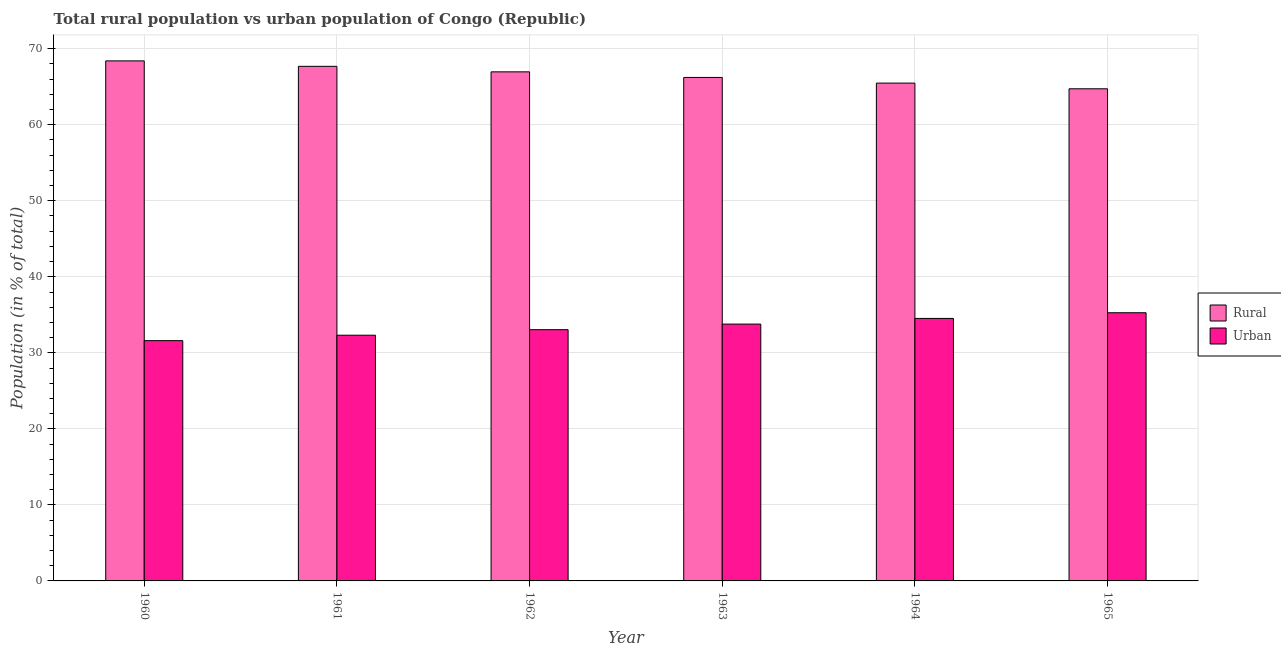How many groups of bars are there?
Your response must be concise. 6. Are the number of bars per tick equal to the number of legend labels?
Ensure brevity in your answer.  Yes. How many bars are there on the 3rd tick from the right?
Provide a short and direct response. 2. What is the rural population in 1964?
Make the answer very short. 65.48. Across all years, what is the maximum rural population?
Offer a terse response. 68.4. Across all years, what is the minimum urban population?
Your answer should be compact. 31.6. In which year was the urban population maximum?
Give a very brief answer. 1965. In which year was the rural population minimum?
Your response must be concise. 1965. What is the total urban population in the graph?
Your answer should be very brief. 200.54. What is the difference between the urban population in 1960 and that in 1963?
Offer a very short reply. -2.18. What is the difference between the urban population in 1960 and the rural population in 1965?
Provide a short and direct response. -3.67. What is the average urban population per year?
Offer a terse response. 33.42. In the year 1964, what is the difference between the urban population and rural population?
Offer a terse response. 0. What is the ratio of the rural population in 1964 to that in 1965?
Offer a terse response. 1.01. What is the difference between the highest and the second highest urban population?
Ensure brevity in your answer.  0.75. What is the difference between the highest and the lowest rural population?
Make the answer very short. 3.67. Is the sum of the rural population in 1961 and 1964 greater than the maximum urban population across all years?
Your response must be concise. Yes. What does the 1st bar from the left in 1964 represents?
Your answer should be compact. Rural. What does the 2nd bar from the right in 1964 represents?
Your response must be concise. Rural. How many bars are there?
Your answer should be compact. 12. Are all the bars in the graph horizontal?
Your answer should be very brief. No. What is the difference between two consecutive major ticks on the Y-axis?
Offer a terse response. 10. Does the graph contain grids?
Keep it short and to the point. Yes. Where does the legend appear in the graph?
Provide a succinct answer. Center right. How many legend labels are there?
Your answer should be compact. 2. How are the legend labels stacked?
Ensure brevity in your answer.  Vertical. What is the title of the graph?
Your answer should be compact. Total rural population vs urban population of Congo (Republic). What is the label or title of the Y-axis?
Provide a succinct answer. Population (in % of total). What is the Population (in % of total) in Rural in 1960?
Your response must be concise. 68.4. What is the Population (in % of total) of Urban in 1960?
Keep it short and to the point. 31.6. What is the Population (in % of total) of Rural in 1961?
Offer a terse response. 67.68. What is the Population (in % of total) in Urban in 1961?
Your answer should be compact. 32.32. What is the Population (in % of total) of Rural in 1962?
Ensure brevity in your answer.  66.95. What is the Population (in % of total) in Urban in 1962?
Your answer should be very brief. 33.05. What is the Population (in % of total) in Rural in 1963?
Your response must be concise. 66.22. What is the Population (in % of total) of Urban in 1963?
Ensure brevity in your answer.  33.78. What is the Population (in % of total) of Rural in 1964?
Provide a succinct answer. 65.48. What is the Population (in % of total) of Urban in 1964?
Ensure brevity in your answer.  34.52. What is the Population (in % of total) of Rural in 1965?
Ensure brevity in your answer.  64.73. What is the Population (in % of total) of Urban in 1965?
Offer a terse response. 35.27. Across all years, what is the maximum Population (in % of total) of Rural?
Keep it short and to the point. 68.4. Across all years, what is the maximum Population (in % of total) of Urban?
Your answer should be very brief. 35.27. Across all years, what is the minimum Population (in % of total) in Rural?
Your answer should be very brief. 64.73. Across all years, what is the minimum Population (in % of total) in Urban?
Your response must be concise. 31.6. What is the total Population (in % of total) in Rural in the graph?
Offer a terse response. 399.46. What is the total Population (in % of total) in Urban in the graph?
Offer a terse response. 200.54. What is the difference between the Population (in % of total) of Rural in 1960 and that in 1961?
Offer a very short reply. 0.72. What is the difference between the Population (in % of total) of Urban in 1960 and that in 1961?
Offer a terse response. -0.72. What is the difference between the Population (in % of total) of Rural in 1960 and that in 1962?
Your answer should be compact. 1.44. What is the difference between the Population (in % of total) of Urban in 1960 and that in 1962?
Your response must be concise. -1.44. What is the difference between the Population (in % of total) of Rural in 1960 and that in 1963?
Provide a short and direct response. 2.18. What is the difference between the Population (in % of total) in Urban in 1960 and that in 1963?
Your answer should be compact. -2.18. What is the difference between the Population (in % of total) in Rural in 1960 and that in 1964?
Your response must be concise. 2.92. What is the difference between the Population (in % of total) in Urban in 1960 and that in 1964?
Your response must be concise. -2.92. What is the difference between the Population (in % of total) of Rural in 1960 and that in 1965?
Offer a very short reply. 3.67. What is the difference between the Population (in % of total) of Urban in 1960 and that in 1965?
Your answer should be very brief. -3.67. What is the difference between the Population (in % of total) of Rural in 1961 and that in 1962?
Offer a terse response. 0.73. What is the difference between the Population (in % of total) of Urban in 1961 and that in 1962?
Your answer should be compact. -0.73. What is the difference between the Population (in % of total) of Rural in 1961 and that in 1963?
Your response must be concise. 1.46. What is the difference between the Population (in % of total) in Urban in 1961 and that in 1963?
Offer a terse response. -1.46. What is the difference between the Population (in % of total) in Rural in 1961 and that in 1964?
Your response must be concise. 2.21. What is the difference between the Population (in % of total) in Urban in 1961 and that in 1964?
Your answer should be compact. -2.21. What is the difference between the Population (in % of total) of Rural in 1961 and that in 1965?
Ensure brevity in your answer.  2.96. What is the difference between the Population (in % of total) of Urban in 1961 and that in 1965?
Provide a short and direct response. -2.96. What is the difference between the Population (in % of total) of Rural in 1962 and that in 1963?
Your response must be concise. 0.73. What is the difference between the Population (in % of total) of Urban in 1962 and that in 1963?
Keep it short and to the point. -0.73. What is the difference between the Population (in % of total) of Rural in 1962 and that in 1964?
Your response must be concise. 1.48. What is the difference between the Population (in % of total) of Urban in 1962 and that in 1964?
Offer a terse response. -1.48. What is the difference between the Population (in % of total) in Rural in 1962 and that in 1965?
Make the answer very short. 2.23. What is the difference between the Population (in % of total) of Urban in 1962 and that in 1965?
Offer a terse response. -2.23. What is the difference between the Population (in % of total) of Rural in 1963 and that in 1964?
Make the answer very short. 0.74. What is the difference between the Population (in % of total) in Urban in 1963 and that in 1964?
Offer a terse response. -0.74. What is the difference between the Population (in % of total) in Rural in 1963 and that in 1965?
Make the answer very short. 1.49. What is the difference between the Population (in % of total) in Urban in 1963 and that in 1965?
Ensure brevity in your answer.  -1.49. What is the difference between the Population (in % of total) in Rural in 1964 and that in 1965?
Make the answer very short. 0.75. What is the difference between the Population (in % of total) of Urban in 1964 and that in 1965?
Keep it short and to the point. -0.75. What is the difference between the Population (in % of total) in Rural in 1960 and the Population (in % of total) in Urban in 1961?
Your answer should be compact. 36.08. What is the difference between the Population (in % of total) of Rural in 1960 and the Population (in % of total) of Urban in 1962?
Provide a succinct answer. 35.35. What is the difference between the Population (in % of total) in Rural in 1960 and the Population (in % of total) in Urban in 1963?
Make the answer very short. 34.62. What is the difference between the Population (in % of total) of Rural in 1960 and the Population (in % of total) of Urban in 1964?
Offer a terse response. 33.88. What is the difference between the Population (in % of total) in Rural in 1960 and the Population (in % of total) in Urban in 1965?
Offer a very short reply. 33.13. What is the difference between the Population (in % of total) of Rural in 1961 and the Population (in % of total) of Urban in 1962?
Keep it short and to the point. 34.64. What is the difference between the Population (in % of total) of Rural in 1961 and the Population (in % of total) of Urban in 1963?
Offer a terse response. 33.9. What is the difference between the Population (in % of total) of Rural in 1961 and the Population (in % of total) of Urban in 1964?
Your answer should be very brief. 33.16. What is the difference between the Population (in % of total) in Rural in 1961 and the Population (in % of total) in Urban in 1965?
Your answer should be very brief. 32.41. What is the difference between the Population (in % of total) in Rural in 1962 and the Population (in % of total) in Urban in 1963?
Your answer should be compact. 33.17. What is the difference between the Population (in % of total) in Rural in 1962 and the Population (in % of total) in Urban in 1964?
Your answer should be compact. 32.43. What is the difference between the Population (in % of total) of Rural in 1962 and the Population (in % of total) of Urban in 1965?
Offer a very short reply. 31.68. What is the difference between the Population (in % of total) in Rural in 1963 and the Population (in % of total) in Urban in 1964?
Make the answer very short. 31.7. What is the difference between the Population (in % of total) of Rural in 1963 and the Population (in % of total) of Urban in 1965?
Offer a very short reply. 30.95. What is the difference between the Population (in % of total) in Rural in 1964 and the Population (in % of total) in Urban in 1965?
Offer a terse response. 30.2. What is the average Population (in % of total) in Rural per year?
Ensure brevity in your answer.  66.58. What is the average Population (in % of total) in Urban per year?
Keep it short and to the point. 33.42. In the year 1960, what is the difference between the Population (in % of total) of Rural and Population (in % of total) of Urban?
Offer a terse response. 36.8. In the year 1961, what is the difference between the Population (in % of total) in Rural and Population (in % of total) in Urban?
Offer a terse response. 35.36. In the year 1962, what is the difference between the Population (in % of total) in Rural and Population (in % of total) in Urban?
Offer a terse response. 33.91. In the year 1963, what is the difference between the Population (in % of total) of Rural and Population (in % of total) of Urban?
Provide a succinct answer. 32.44. In the year 1964, what is the difference between the Population (in % of total) of Rural and Population (in % of total) of Urban?
Make the answer very short. 30.95. In the year 1965, what is the difference between the Population (in % of total) in Rural and Population (in % of total) in Urban?
Your answer should be compact. 29.45. What is the ratio of the Population (in % of total) in Rural in 1960 to that in 1961?
Give a very brief answer. 1.01. What is the ratio of the Population (in % of total) in Urban in 1960 to that in 1961?
Keep it short and to the point. 0.98. What is the ratio of the Population (in % of total) in Rural in 1960 to that in 1962?
Your response must be concise. 1.02. What is the ratio of the Population (in % of total) of Urban in 1960 to that in 1962?
Ensure brevity in your answer.  0.96. What is the ratio of the Population (in % of total) in Rural in 1960 to that in 1963?
Provide a short and direct response. 1.03. What is the ratio of the Population (in % of total) of Urban in 1960 to that in 1963?
Ensure brevity in your answer.  0.94. What is the ratio of the Population (in % of total) of Rural in 1960 to that in 1964?
Give a very brief answer. 1.04. What is the ratio of the Population (in % of total) in Urban in 1960 to that in 1964?
Your answer should be compact. 0.92. What is the ratio of the Population (in % of total) in Rural in 1960 to that in 1965?
Keep it short and to the point. 1.06. What is the ratio of the Population (in % of total) of Urban in 1960 to that in 1965?
Your answer should be compact. 0.9. What is the ratio of the Population (in % of total) in Rural in 1961 to that in 1962?
Offer a very short reply. 1.01. What is the ratio of the Population (in % of total) in Rural in 1961 to that in 1963?
Ensure brevity in your answer.  1.02. What is the ratio of the Population (in % of total) in Urban in 1961 to that in 1963?
Your answer should be very brief. 0.96. What is the ratio of the Population (in % of total) of Rural in 1961 to that in 1964?
Your answer should be compact. 1.03. What is the ratio of the Population (in % of total) in Urban in 1961 to that in 1964?
Ensure brevity in your answer.  0.94. What is the ratio of the Population (in % of total) in Rural in 1961 to that in 1965?
Make the answer very short. 1.05. What is the ratio of the Population (in % of total) in Urban in 1961 to that in 1965?
Give a very brief answer. 0.92. What is the ratio of the Population (in % of total) of Rural in 1962 to that in 1963?
Your response must be concise. 1.01. What is the ratio of the Population (in % of total) of Urban in 1962 to that in 1963?
Keep it short and to the point. 0.98. What is the ratio of the Population (in % of total) in Rural in 1962 to that in 1964?
Make the answer very short. 1.02. What is the ratio of the Population (in % of total) in Urban in 1962 to that in 1964?
Give a very brief answer. 0.96. What is the ratio of the Population (in % of total) in Rural in 1962 to that in 1965?
Provide a short and direct response. 1.03. What is the ratio of the Population (in % of total) of Urban in 1962 to that in 1965?
Give a very brief answer. 0.94. What is the ratio of the Population (in % of total) of Rural in 1963 to that in 1964?
Provide a succinct answer. 1.01. What is the ratio of the Population (in % of total) in Urban in 1963 to that in 1964?
Your answer should be compact. 0.98. What is the ratio of the Population (in % of total) of Rural in 1963 to that in 1965?
Offer a very short reply. 1.02. What is the ratio of the Population (in % of total) in Urban in 1963 to that in 1965?
Make the answer very short. 0.96. What is the ratio of the Population (in % of total) of Rural in 1964 to that in 1965?
Provide a succinct answer. 1.01. What is the ratio of the Population (in % of total) of Urban in 1964 to that in 1965?
Give a very brief answer. 0.98. What is the difference between the highest and the second highest Population (in % of total) of Rural?
Offer a terse response. 0.72. What is the difference between the highest and the second highest Population (in % of total) in Urban?
Give a very brief answer. 0.75. What is the difference between the highest and the lowest Population (in % of total) of Rural?
Your answer should be very brief. 3.67. What is the difference between the highest and the lowest Population (in % of total) of Urban?
Your response must be concise. 3.67. 